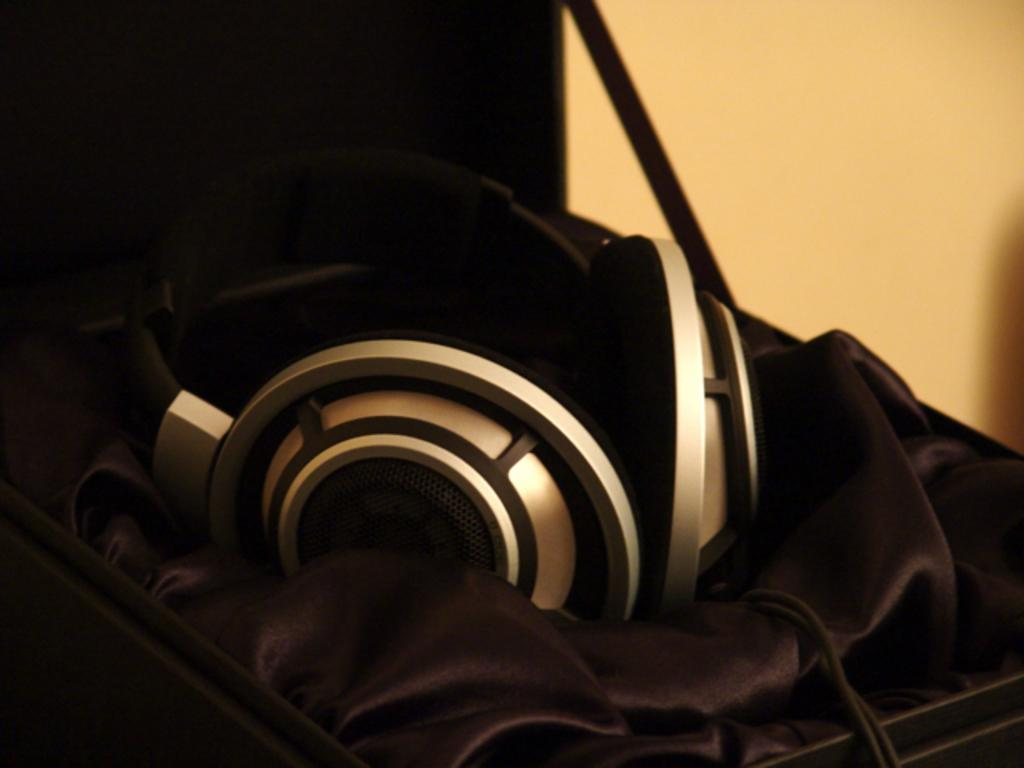What can be seen in the image that is used for listening to audio? There is a headset in the image that is used for listening to audio. How is the headset placed in the image? The headset is on a cloth in the image. Where is the cloth with the headset located? The cloth with the headset is in a box. What is the state of the box in the image? The box is opened in the image. What can be seen in the background of the image? There is a wall in the background of the image. How many tickets are visible in the image? There are no tickets present in the image. What type of lumber is being used to support the wall in the image? There is no lumber visible in the image, and the wall's support structure is not shown. 